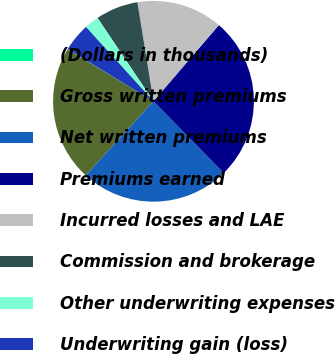Convert chart to OTSL. <chart><loc_0><loc_0><loc_500><loc_500><pie_chart><fcel>(Dollars in thousands)<fcel>Gross written premiums<fcel>Net written premiums<fcel>Premiums earned<fcel>Incurred losses and LAE<fcel>Commission and brokerage<fcel>Other underwriting expenses<fcel>Underwriting gain (loss)<nl><fcel>0.05%<fcel>21.85%<fcel>24.12%<fcel>26.38%<fcel>13.85%<fcel>6.85%<fcel>2.32%<fcel>4.58%<nl></chart> 